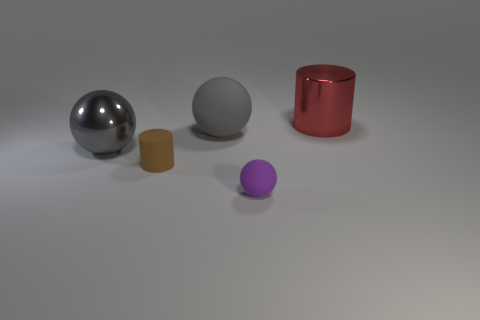Add 2 big red objects. How many objects exist? 7 Subtract all spheres. How many objects are left? 2 Subtract 0 blue cylinders. How many objects are left? 5 Subtract all red shiny cylinders. Subtract all small brown objects. How many objects are left? 3 Add 3 tiny purple rubber things. How many tiny purple rubber things are left? 4 Add 3 tiny brown cylinders. How many tiny brown cylinders exist? 4 